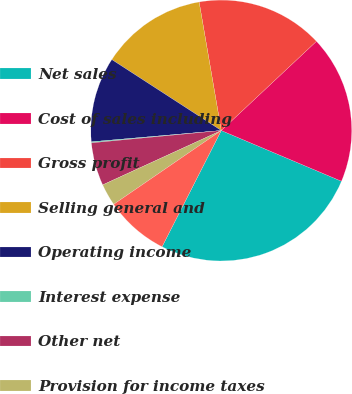Convert chart. <chart><loc_0><loc_0><loc_500><loc_500><pie_chart><fcel>Net sales<fcel>Cost of sales including<fcel>Gross profit<fcel>Selling general and<fcel>Operating income<fcel>Interest expense<fcel>Other net<fcel>Provision for income taxes<fcel>Net income<nl><fcel>26.14%<fcel>18.34%<fcel>15.73%<fcel>13.13%<fcel>10.53%<fcel>0.13%<fcel>5.33%<fcel>2.73%<fcel>7.93%<nl></chart> 